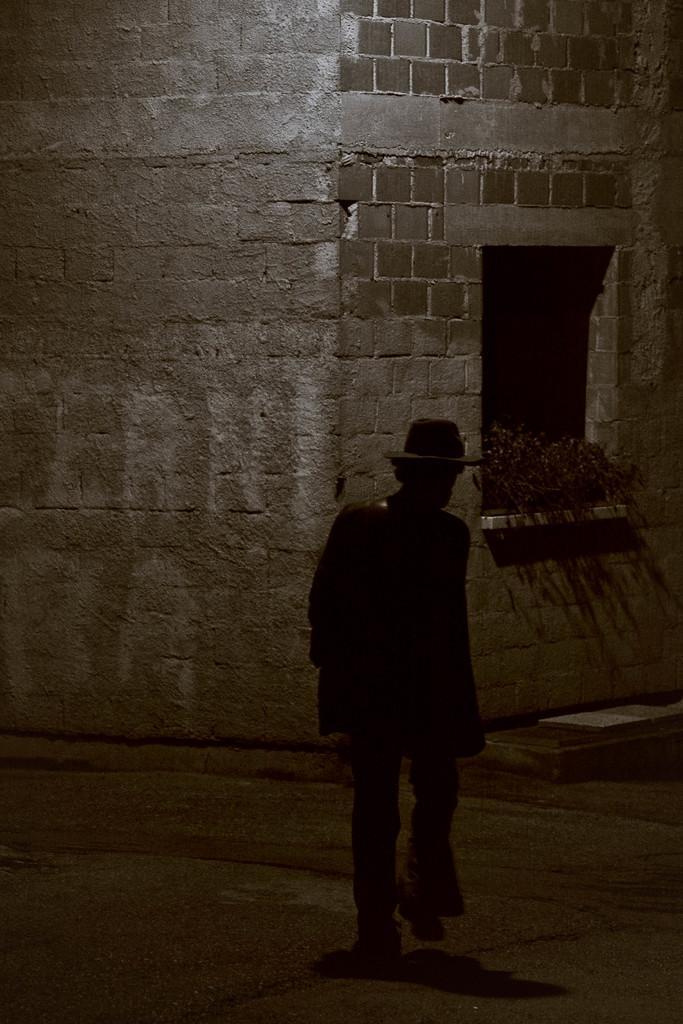In one or two sentences, can you explain what this image depicts? In the image there is a building constructed with bricks, there are few plants in front of the window of the building and a person is walking on a path in front of that building. 